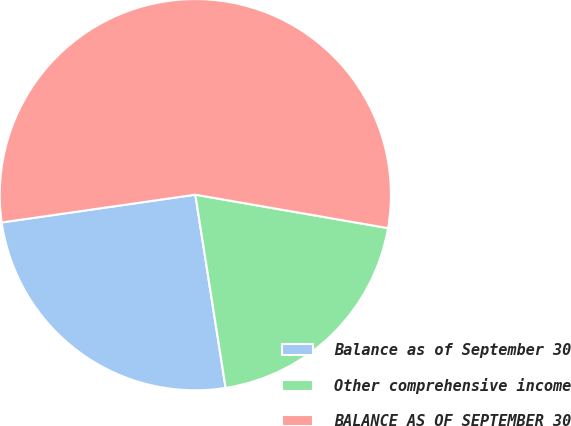<chart> <loc_0><loc_0><loc_500><loc_500><pie_chart><fcel>Balance as of September 30<fcel>Other comprehensive income<fcel>BALANCE AS OF SEPTEMBER 30<nl><fcel>25.21%<fcel>19.79%<fcel>55.01%<nl></chart> 